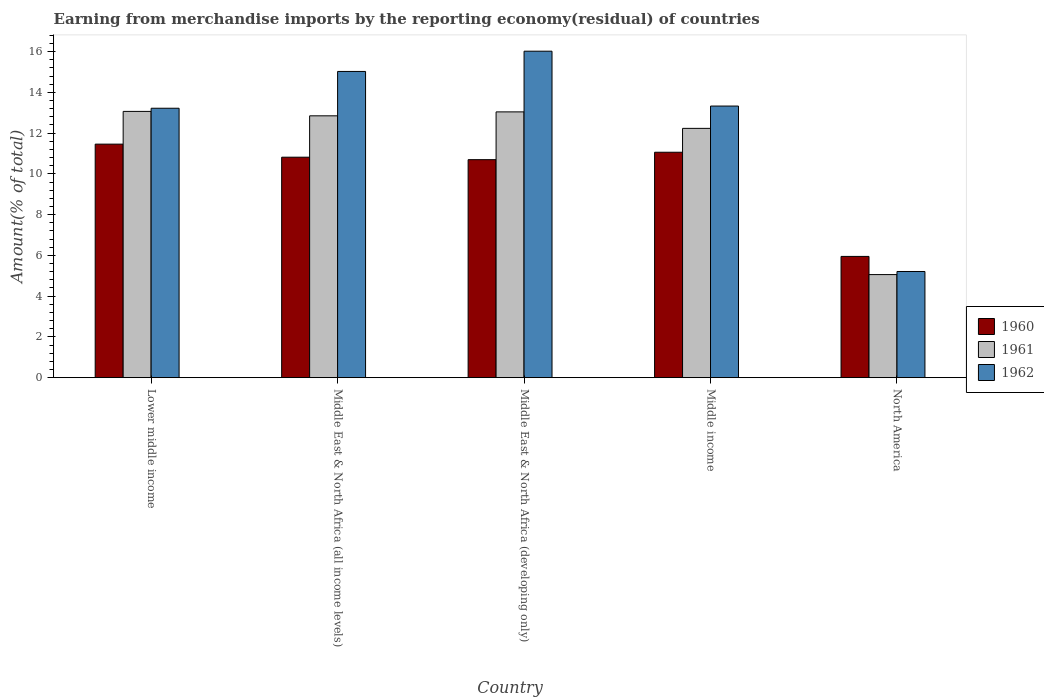How many different coloured bars are there?
Give a very brief answer. 3. How many bars are there on the 3rd tick from the right?
Make the answer very short. 3. What is the label of the 2nd group of bars from the left?
Provide a succinct answer. Middle East & North Africa (all income levels). In how many cases, is the number of bars for a given country not equal to the number of legend labels?
Your answer should be very brief. 0. What is the percentage of amount earned from merchandise imports in 1962 in Middle income?
Offer a terse response. 13.33. Across all countries, what is the maximum percentage of amount earned from merchandise imports in 1961?
Your answer should be compact. 13.06. Across all countries, what is the minimum percentage of amount earned from merchandise imports in 1962?
Your response must be concise. 5.21. In which country was the percentage of amount earned from merchandise imports in 1960 maximum?
Your answer should be compact. Lower middle income. In which country was the percentage of amount earned from merchandise imports in 1962 minimum?
Make the answer very short. North America. What is the total percentage of amount earned from merchandise imports in 1960 in the graph?
Your answer should be compact. 49.98. What is the difference between the percentage of amount earned from merchandise imports in 1960 in Middle income and that in North America?
Your response must be concise. 5.11. What is the difference between the percentage of amount earned from merchandise imports in 1961 in Middle East & North Africa (all income levels) and the percentage of amount earned from merchandise imports in 1962 in Middle East & North Africa (developing only)?
Make the answer very short. -3.17. What is the average percentage of amount earned from merchandise imports in 1962 per country?
Make the answer very short. 12.56. What is the difference between the percentage of amount earned from merchandise imports of/in 1961 and percentage of amount earned from merchandise imports of/in 1962 in Middle East & North Africa (all income levels)?
Offer a very short reply. -2.18. In how many countries, is the percentage of amount earned from merchandise imports in 1962 greater than 4.4 %?
Your response must be concise. 5. What is the ratio of the percentage of amount earned from merchandise imports in 1962 in Lower middle income to that in Middle East & North Africa (developing only)?
Provide a short and direct response. 0.83. Is the percentage of amount earned from merchandise imports in 1960 in Middle East & North Africa (all income levels) less than that in Middle income?
Ensure brevity in your answer.  Yes. What is the difference between the highest and the second highest percentage of amount earned from merchandise imports in 1962?
Ensure brevity in your answer.  2.69. What is the difference between the highest and the lowest percentage of amount earned from merchandise imports in 1961?
Provide a short and direct response. 8.01. Is it the case that in every country, the sum of the percentage of amount earned from merchandise imports in 1960 and percentage of amount earned from merchandise imports in 1962 is greater than the percentage of amount earned from merchandise imports in 1961?
Your answer should be compact. Yes. How many bars are there?
Your answer should be very brief. 15. What is the difference between two consecutive major ticks on the Y-axis?
Offer a terse response. 2. Does the graph contain any zero values?
Ensure brevity in your answer.  No. Does the graph contain grids?
Give a very brief answer. No. How are the legend labels stacked?
Make the answer very short. Vertical. What is the title of the graph?
Your response must be concise. Earning from merchandise imports by the reporting economy(residual) of countries. Does "1991" appear as one of the legend labels in the graph?
Provide a short and direct response. No. What is the label or title of the Y-axis?
Your response must be concise. Amount(% of total). What is the Amount(% of total) of 1960 in Lower middle income?
Offer a terse response. 11.46. What is the Amount(% of total) of 1961 in Lower middle income?
Provide a succinct answer. 13.06. What is the Amount(% of total) in 1962 in Lower middle income?
Your response must be concise. 13.22. What is the Amount(% of total) in 1960 in Middle East & North Africa (all income levels)?
Your response must be concise. 10.82. What is the Amount(% of total) in 1961 in Middle East & North Africa (all income levels)?
Keep it short and to the point. 12.85. What is the Amount(% of total) in 1962 in Middle East & North Africa (all income levels)?
Provide a succinct answer. 15.03. What is the Amount(% of total) of 1960 in Middle East & North Africa (developing only)?
Offer a terse response. 10.7. What is the Amount(% of total) in 1961 in Middle East & North Africa (developing only)?
Provide a succinct answer. 13.04. What is the Amount(% of total) in 1962 in Middle East & North Africa (developing only)?
Give a very brief answer. 16.02. What is the Amount(% of total) of 1960 in Middle income?
Offer a terse response. 11.06. What is the Amount(% of total) in 1961 in Middle income?
Provide a succinct answer. 12.23. What is the Amount(% of total) in 1962 in Middle income?
Make the answer very short. 13.33. What is the Amount(% of total) in 1960 in North America?
Provide a succinct answer. 5.95. What is the Amount(% of total) in 1961 in North America?
Give a very brief answer. 5.06. What is the Amount(% of total) of 1962 in North America?
Offer a very short reply. 5.21. Across all countries, what is the maximum Amount(% of total) in 1960?
Make the answer very short. 11.46. Across all countries, what is the maximum Amount(% of total) of 1961?
Your response must be concise. 13.06. Across all countries, what is the maximum Amount(% of total) in 1962?
Ensure brevity in your answer.  16.02. Across all countries, what is the minimum Amount(% of total) of 1960?
Keep it short and to the point. 5.95. Across all countries, what is the minimum Amount(% of total) in 1961?
Your response must be concise. 5.06. Across all countries, what is the minimum Amount(% of total) in 1962?
Ensure brevity in your answer.  5.21. What is the total Amount(% of total) in 1960 in the graph?
Make the answer very short. 49.98. What is the total Amount(% of total) in 1961 in the graph?
Ensure brevity in your answer.  56.24. What is the total Amount(% of total) of 1962 in the graph?
Ensure brevity in your answer.  62.8. What is the difference between the Amount(% of total) in 1960 in Lower middle income and that in Middle East & North Africa (all income levels)?
Your answer should be very brief. 0.64. What is the difference between the Amount(% of total) of 1961 in Lower middle income and that in Middle East & North Africa (all income levels)?
Your answer should be very brief. 0.22. What is the difference between the Amount(% of total) of 1962 in Lower middle income and that in Middle East & North Africa (all income levels)?
Provide a short and direct response. -1.81. What is the difference between the Amount(% of total) of 1960 in Lower middle income and that in Middle East & North Africa (developing only)?
Offer a very short reply. 0.76. What is the difference between the Amount(% of total) in 1961 in Lower middle income and that in Middle East & North Africa (developing only)?
Make the answer very short. 0.02. What is the difference between the Amount(% of total) in 1962 in Lower middle income and that in Middle East & North Africa (developing only)?
Provide a short and direct response. -2.8. What is the difference between the Amount(% of total) of 1960 in Lower middle income and that in Middle income?
Your answer should be compact. 0.4. What is the difference between the Amount(% of total) in 1961 in Lower middle income and that in Middle income?
Give a very brief answer. 0.83. What is the difference between the Amount(% of total) of 1962 in Lower middle income and that in Middle income?
Keep it short and to the point. -0.11. What is the difference between the Amount(% of total) in 1960 in Lower middle income and that in North America?
Provide a short and direct response. 5.51. What is the difference between the Amount(% of total) of 1961 in Lower middle income and that in North America?
Your answer should be compact. 8.01. What is the difference between the Amount(% of total) in 1962 in Lower middle income and that in North America?
Your answer should be very brief. 8.01. What is the difference between the Amount(% of total) in 1960 in Middle East & North Africa (all income levels) and that in Middle East & North Africa (developing only)?
Your response must be concise. 0.12. What is the difference between the Amount(% of total) of 1961 in Middle East & North Africa (all income levels) and that in Middle East & North Africa (developing only)?
Provide a succinct answer. -0.19. What is the difference between the Amount(% of total) in 1962 in Middle East & North Africa (all income levels) and that in Middle East & North Africa (developing only)?
Offer a very short reply. -0.99. What is the difference between the Amount(% of total) of 1960 in Middle East & North Africa (all income levels) and that in Middle income?
Offer a very short reply. -0.24. What is the difference between the Amount(% of total) in 1961 in Middle East & North Africa (all income levels) and that in Middle income?
Offer a terse response. 0.62. What is the difference between the Amount(% of total) of 1962 in Middle East & North Africa (all income levels) and that in Middle income?
Give a very brief answer. 1.7. What is the difference between the Amount(% of total) of 1960 in Middle East & North Africa (all income levels) and that in North America?
Offer a terse response. 4.87. What is the difference between the Amount(% of total) of 1961 in Middle East & North Africa (all income levels) and that in North America?
Your response must be concise. 7.79. What is the difference between the Amount(% of total) of 1962 in Middle East & North Africa (all income levels) and that in North America?
Make the answer very short. 9.82. What is the difference between the Amount(% of total) in 1960 in Middle East & North Africa (developing only) and that in Middle income?
Your response must be concise. -0.36. What is the difference between the Amount(% of total) in 1961 in Middle East & North Africa (developing only) and that in Middle income?
Ensure brevity in your answer.  0.81. What is the difference between the Amount(% of total) in 1962 in Middle East & North Africa (developing only) and that in Middle income?
Provide a succinct answer. 2.69. What is the difference between the Amount(% of total) of 1960 in Middle East & North Africa (developing only) and that in North America?
Make the answer very short. 4.75. What is the difference between the Amount(% of total) in 1961 in Middle East & North Africa (developing only) and that in North America?
Your answer should be compact. 7.98. What is the difference between the Amount(% of total) of 1962 in Middle East & North Africa (developing only) and that in North America?
Your response must be concise. 10.81. What is the difference between the Amount(% of total) in 1960 in Middle income and that in North America?
Make the answer very short. 5.11. What is the difference between the Amount(% of total) of 1961 in Middle income and that in North America?
Ensure brevity in your answer.  7.17. What is the difference between the Amount(% of total) of 1962 in Middle income and that in North America?
Provide a succinct answer. 8.12. What is the difference between the Amount(% of total) of 1960 in Lower middle income and the Amount(% of total) of 1961 in Middle East & North Africa (all income levels)?
Ensure brevity in your answer.  -1.39. What is the difference between the Amount(% of total) in 1960 in Lower middle income and the Amount(% of total) in 1962 in Middle East & North Africa (all income levels)?
Your answer should be very brief. -3.57. What is the difference between the Amount(% of total) of 1961 in Lower middle income and the Amount(% of total) of 1962 in Middle East & North Africa (all income levels)?
Make the answer very short. -1.96. What is the difference between the Amount(% of total) of 1960 in Lower middle income and the Amount(% of total) of 1961 in Middle East & North Africa (developing only)?
Offer a terse response. -1.58. What is the difference between the Amount(% of total) in 1960 in Lower middle income and the Amount(% of total) in 1962 in Middle East & North Africa (developing only)?
Give a very brief answer. -4.56. What is the difference between the Amount(% of total) of 1961 in Lower middle income and the Amount(% of total) of 1962 in Middle East & North Africa (developing only)?
Offer a terse response. -2.95. What is the difference between the Amount(% of total) of 1960 in Lower middle income and the Amount(% of total) of 1961 in Middle income?
Provide a short and direct response. -0.77. What is the difference between the Amount(% of total) in 1960 in Lower middle income and the Amount(% of total) in 1962 in Middle income?
Give a very brief answer. -1.87. What is the difference between the Amount(% of total) in 1961 in Lower middle income and the Amount(% of total) in 1962 in Middle income?
Provide a short and direct response. -0.26. What is the difference between the Amount(% of total) of 1960 in Lower middle income and the Amount(% of total) of 1961 in North America?
Make the answer very short. 6.4. What is the difference between the Amount(% of total) of 1960 in Lower middle income and the Amount(% of total) of 1962 in North America?
Offer a very short reply. 6.25. What is the difference between the Amount(% of total) of 1961 in Lower middle income and the Amount(% of total) of 1962 in North America?
Your answer should be compact. 7.86. What is the difference between the Amount(% of total) in 1960 in Middle East & North Africa (all income levels) and the Amount(% of total) in 1961 in Middle East & North Africa (developing only)?
Give a very brief answer. -2.22. What is the difference between the Amount(% of total) of 1960 in Middle East & North Africa (all income levels) and the Amount(% of total) of 1962 in Middle East & North Africa (developing only)?
Your answer should be compact. -5.2. What is the difference between the Amount(% of total) in 1961 in Middle East & North Africa (all income levels) and the Amount(% of total) in 1962 in Middle East & North Africa (developing only)?
Make the answer very short. -3.17. What is the difference between the Amount(% of total) in 1960 in Middle East & North Africa (all income levels) and the Amount(% of total) in 1961 in Middle income?
Make the answer very short. -1.41. What is the difference between the Amount(% of total) in 1960 in Middle East & North Africa (all income levels) and the Amount(% of total) in 1962 in Middle income?
Provide a succinct answer. -2.51. What is the difference between the Amount(% of total) of 1961 in Middle East & North Africa (all income levels) and the Amount(% of total) of 1962 in Middle income?
Provide a short and direct response. -0.48. What is the difference between the Amount(% of total) of 1960 in Middle East & North Africa (all income levels) and the Amount(% of total) of 1961 in North America?
Make the answer very short. 5.76. What is the difference between the Amount(% of total) of 1960 in Middle East & North Africa (all income levels) and the Amount(% of total) of 1962 in North America?
Ensure brevity in your answer.  5.61. What is the difference between the Amount(% of total) in 1961 in Middle East & North Africa (all income levels) and the Amount(% of total) in 1962 in North America?
Your answer should be compact. 7.64. What is the difference between the Amount(% of total) in 1960 in Middle East & North Africa (developing only) and the Amount(% of total) in 1961 in Middle income?
Offer a very short reply. -1.54. What is the difference between the Amount(% of total) in 1960 in Middle East & North Africa (developing only) and the Amount(% of total) in 1962 in Middle income?
Your response must be concise. -2.63. What is the difference between the Amount(% of total) of 1961 in Middle East & North Africa (developing only) and the Amount(% of total) of 1962 in Middle income?
Your answer should be compact. -0.29. What is the difference between the Amount(% of total) of 1960 in Middle East & North Africa (developing only) and the Amount(% of total) of 1961 in North America?
Offer a very short reply. 5.64. What is the difference between the Amount(% of total) of 1960 in Middle East & North Africa (developing only) and the Amount(% of total) of 1962 in North America?
Provide a short and direct response. 5.49. What is the difference between the Amount(% of total) in 1961 in Middle East & North Africa (developing only) and the Amount(% of total) in 1962 in North America?
Your answer should be very brief. 7.83. What is the difference between the Amount(% of total) in 1960 in Middle income and the Amount(% of total) in 1961 in North America?
Offer a very short reply. 6. What is the difference between the Amount(% of total) in 1960 in Middle income and the Amount(% of total) in 1962 in North America?
Your answer should be very brief. 5.85. What is the difference between the Amount(% of total) in 1961 in Middle income and the Amount(% of total) in 1962 in North America?
Provide a short and direct response. 7.02. What is the average Amount(% of total) of 1960 per country?
Your answer should be very brief. 10. What is the average Amount(% of total) in 1961 per country?
Make the answer very short. 11.25. What is the average Amount(% of total) of 1962 per country?
Give a very brief answer. 12.56. What is the difference between the Amount(% of total) in 1960 and Amount(% of total) in 1961 in Lower middle income?
Your answer should be very brief. -1.61. What is the difference between the Amount(% of total) in 1960 and Amount(% of total) in 1962 in Lower middle income?
Ensure brevity in your answer.  -1.76. What is the difference between the Amount(% of total) in 1961 and Amount(% of total) in 1962 in Lower middle income?
Provide a succinct answer. -0.16. What is the difference between the Amount(% of total) in 1960 and Amount(% of total) in 1961 in Middle East & North Africa (all income levels)?
Your response must be concise. -2.03. What is the difference between the Amount(% of total) of 1960 and Amount(% of total) of 1962 in Middle East & North Africa (all income levels)?
Your answer should be very brief. -4.21. What is the difference between the Amount(% of total) in 1961 and Amount(% of total) in 1962 in Middle East & North Africa (all income levels)?
Offer a very short reply. -2.18. What is the difference between the Amount(% of total) in 1960 and Amount(% of total) in 1961 in Middle East & North Africa (developing only)?
Provide a short and direct response. -2.34. What is the difference between the Amount(% of total) of 1960 and Amount(% of total) of 1962 in Middle East & North Africa (developing only)?
Your answer should be compact. -5.32. What is the difference between the Amount(% of total) in 1961 and Amount(% of total) in 1962 in Middle East & North Africa (developing only)?
Offer a terse response. -2.98. What is the difference between the Amount(% of total) in 1960 and Amount(% of total) in 1961 in Middle income?
Your answer should be compact. -1.17. What is the difference between the Amount(% of total) in 1960 and Amount(% of total) in 1962 in Middle income?
Your answer should be compact. -2.27. What is the difference between the Amount(% of total) of 1961 and Amount(% of total) of 1962 in Middle income?
Your answer should be very brief. -1.09. What is the difference between the Amount(% of total) of 1960 and Amount(% of total) of 1961 in North America?
Make the answer very short. 0.89. What is the difference between the Amount(% of total) of 1960 and Amount(% of total) of 1962 in North America?
Offer a very short reply. 0.74. What is the difference between the Amount(% of total) in 1961 and Amount(% of total) in 1962 in North America?
Your answer should be compact. -0.15. What is the ratio of the Amount(% of total) of 1960 in Lower middle income to that in Middle East & North Africa (all income levels)?
Your answer should be compact. 1.06. What is the ratio of the Amount(% of total) of 1961 in Lower middle income to that in Middle East & North Africa (all income levels)?
Keep it short and to the point. 1.02. What is the ratio of the Amount(% of total) of 1962 in Lower middle income to that in Middle East & North Africa (all income levels)?
Give a very brief answer. 0.88. What is the ratio of the Amount(% of total) of 1960 in Lower middle income to that in Middle East & North Africa (developing only)?
Offer a terse response. 1.07. What is the ratio of the Amount(% of total) of 1961 in Lower middle income to that in Middle East & North Africa (developing only)?
Give a very brief answer. 1. What is the ratio of the Amount(% of total) of 1962 in Lower middle income to that in Middle East & North Africa (developing only)?
Offer a terse response. 0.83. What is the ratio of the Amount(% of total) of 1960 in Lower middle income to that in Middle income?
Provide a short and direct response. 1.04. What is the ratio of the Amount(% of total) in 1961 in Lower middle income to that in Middle income?
Provide a succinct answer. 1.07. What is the ratio of the Amount(% of total) in 1962 in Lower middle income to that in Middle income?
Provide a succinct answer. 0.99. What is the ratio of the Amount(% of total) of 1960 in Lower middle income to that in North America?
Your answer should be very brief. 1.93. What is the ratio of the Amount(% of total) of 1961 in Lower middle income to that in North America?
Provide a short and direct response. 2.58. What is the ratio of the Amount(% of total) of 1962 in Lower middle income to that in North America?
Give a very brief answer. 2.54. What is the ratio of the Amount(% of total) in 1960 in Middle East & North Africa (all income levels) to that in Middle East & North Africa (developing only)?
Offer a very short reply. 1.01. What is the ratio of the Amount(% of total) of 1961 in Middle East & North Africa (all income levels) to that in Middle East & North Africa (developing only)?
Provide a succinct answer. 0.99. What is the ratio of the Amount(% of total) in 1962 in Middle East & North Africa (all income levels) to that in Middle East & North Africa (developing only)?
Ensure brevity in your answer.  0.94. What is the ratio of the Amount(% of total) in 1961 in Middle East & North Africa (all income levels) to that in Middle income?
Offer a terse response. 1.05. What is the ratio of the Amount(% of total) of 1962 in Middle East & North Africa (all income levels) to that in Middle income?
Keep it short and to the point. 1.13. What is the ratio of the Amount(% of total) of 1960 in Middle East & North Africa (all income levels) to that in North America?
Make the answer very short. 1.82. What is the ratio of the Amount(% of total) in 1961 in Middle East & North Africa (all income levels) to that in North America?
Provide a succinct answer. 2.54. What is the ratio of the Amount(% of total) in 1962 in Middle East & North Africa (all income levels) to that in North America?
Ensure brevity in your answer.  2.88. What is the ratio of the Amount(% of total) in 1960 in Middle East & North Africa (developing only) to that in Middle income?
Provide a succinct answer. 0.97. What is the ratio of the Amount(% of total) in 1961 in Middle East & North Africa (developing only) to that in Middle income?
Offer a terse response. 1.07. What is the ratio of the Amount(% of total) of 1962 in Middle East & North Africa (developing only) to that in Middle income?
Keep it short and to the point. 1.2. What is the ratio of the Amount(% of total) of 1960 in Middle East & North Africa (developing only) to that in North America?
Your answer should be very brief. 1.8. What is the ratio of the Amount(% of total) in 1961 in Middle East & North Africa (developing only) to that in North America?
Offer a very short reply. 2.58. What is the ratio of the Amount(% of total) of 1962 in Middle East & North Africa (developing only) to that in North America?
Make the answer very short. 3.07. What is the ratio of the Amount(% of total) of 1960 in Middle income to that in North America?
Give a very brief answer. 1.86. What is the ratio of the Amount(% of total) of 1961 in Middle income to that in North America?
Keep it short and to the point. 2.42. What is the ratio of the Amount(% of total) of 1962 in Middle income to that in North America?
Ensure brevity in your answer.  2.56. What is the difference between the highest and the second highest Amount(% of total) in 1960?
Your response must be concise. 0.4. What is the difference between the highest and the second highest Amount(% of total) in 1961?
Provide a succinct answer. 0.02. What is the difference between the highest and the second highest Amount(% of total) of 1962?
Provide a short and direct response. 0.99. What is the difference between the highest and the lowest Amount(% of total) in 1960?
Offer a terse response. 5.51. What is the difference between the highest and the lowest Amount(% of total) in 1961?
Provide a short and direct response. 8.01. What is the difference between the highest and the lowest Amount(% of total) in 1962?
Give a very brief answer. 10.81. 